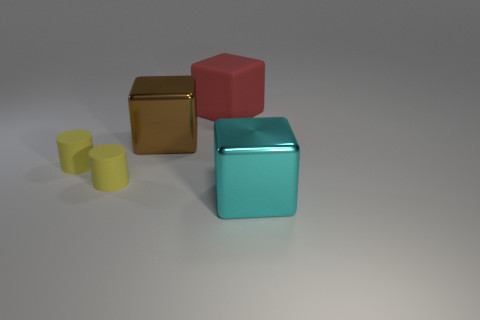Add 5 brown metallic things. How many objects exist? 10 Subtract all cylinders. How many objects are left? 3 Add 4 brown things. How many brown things are left? 5 Add 3 big brown balls. How many big brown balls exist? 3 Subtract 0 gray blocks. How many objects are left? 5 Subtract all cyan metal blocks. Subtract all cyan cubes. How many objects are left? 3 